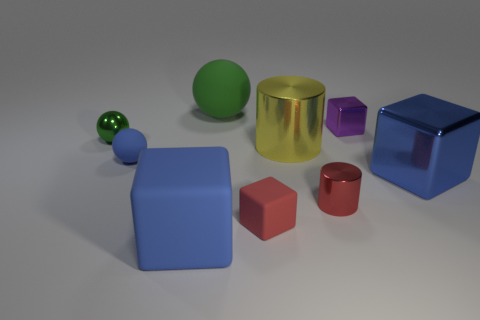Subtract all green spheres. How many were subtracted if there are1green spheres left? 1 Subtract all large blue shiny blocks. How many blocks are left? 3 Subtract 3 balls. How many balls are left? 0 Subtract all purple blocks. How many blocks are left? 3 Subtract all cyan cubes. How many green balls are left? 2 Subtract all cylinders. How many objects are left? 7 Add 4 blue matte things. How many blue matte things are left? 6 Add 6 gray rubber cylinders. How many gray rubber cylinders exist? 6 Subtract 0 red balls. How many objects are left? 9 Subtract all brown balls. Subtract all cyan cylinders. How many balls are left? 3 